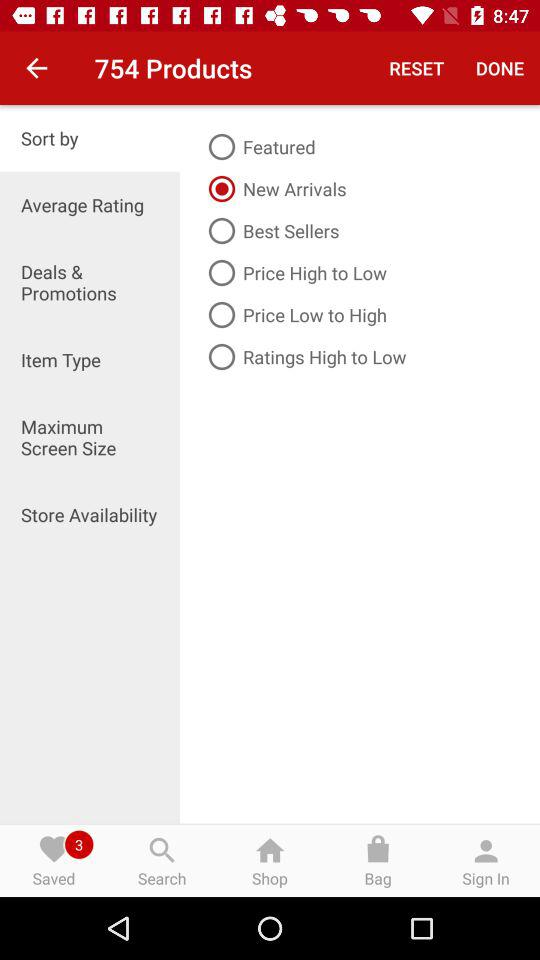How many products are there? There are 754 products. 